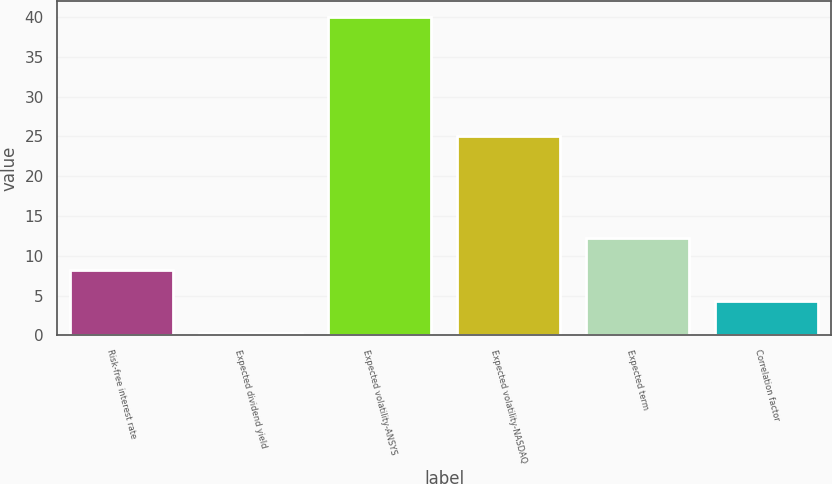Convert chart. <chart><loc_0><loc_0><loc_500><loc_500><bar_chart><fcel>Risk-free interest rate<fcel>Expected dividend yield<fcel>Expected volatility-ANSYS<fcel>Expected volatility-NASDAQ<fcel>Expected term<fcel>Correlation factor<nl><fcel>8.25<fcel>0.31<fcel>40<fcel>25<fcel>12.22<fcel>4.28<nl></chart> 